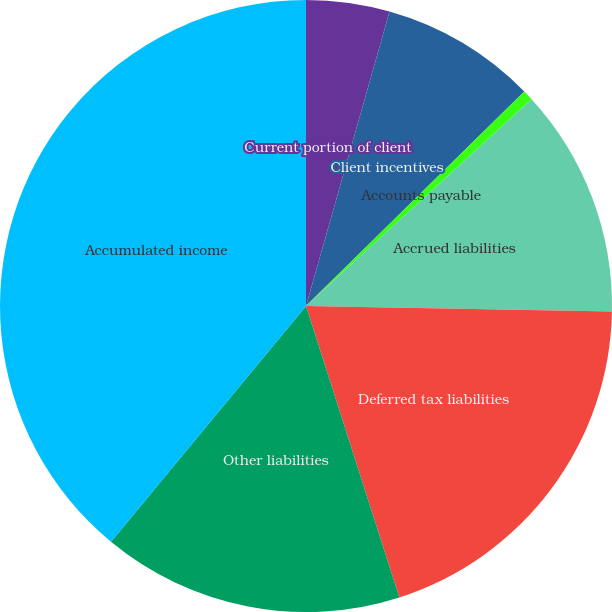Convert chart. <chart><loc_0><loc_0><loc_500><loc_500><pie_chart><fcel>Current portion of client<fcel>Client incentives<fcel>Accounts payable<fcel>Accrued liabilities<fcel>Deferred tax liabilities<fcel>Other liabilities<fcel>Accumulated income<nl><fcel>4.4%<fcel>8.24%<fcel>0.55%<fcel>12.09%<fcel>19.78%<fcel>15.93%<fcel>39.0%<nl></chart> 